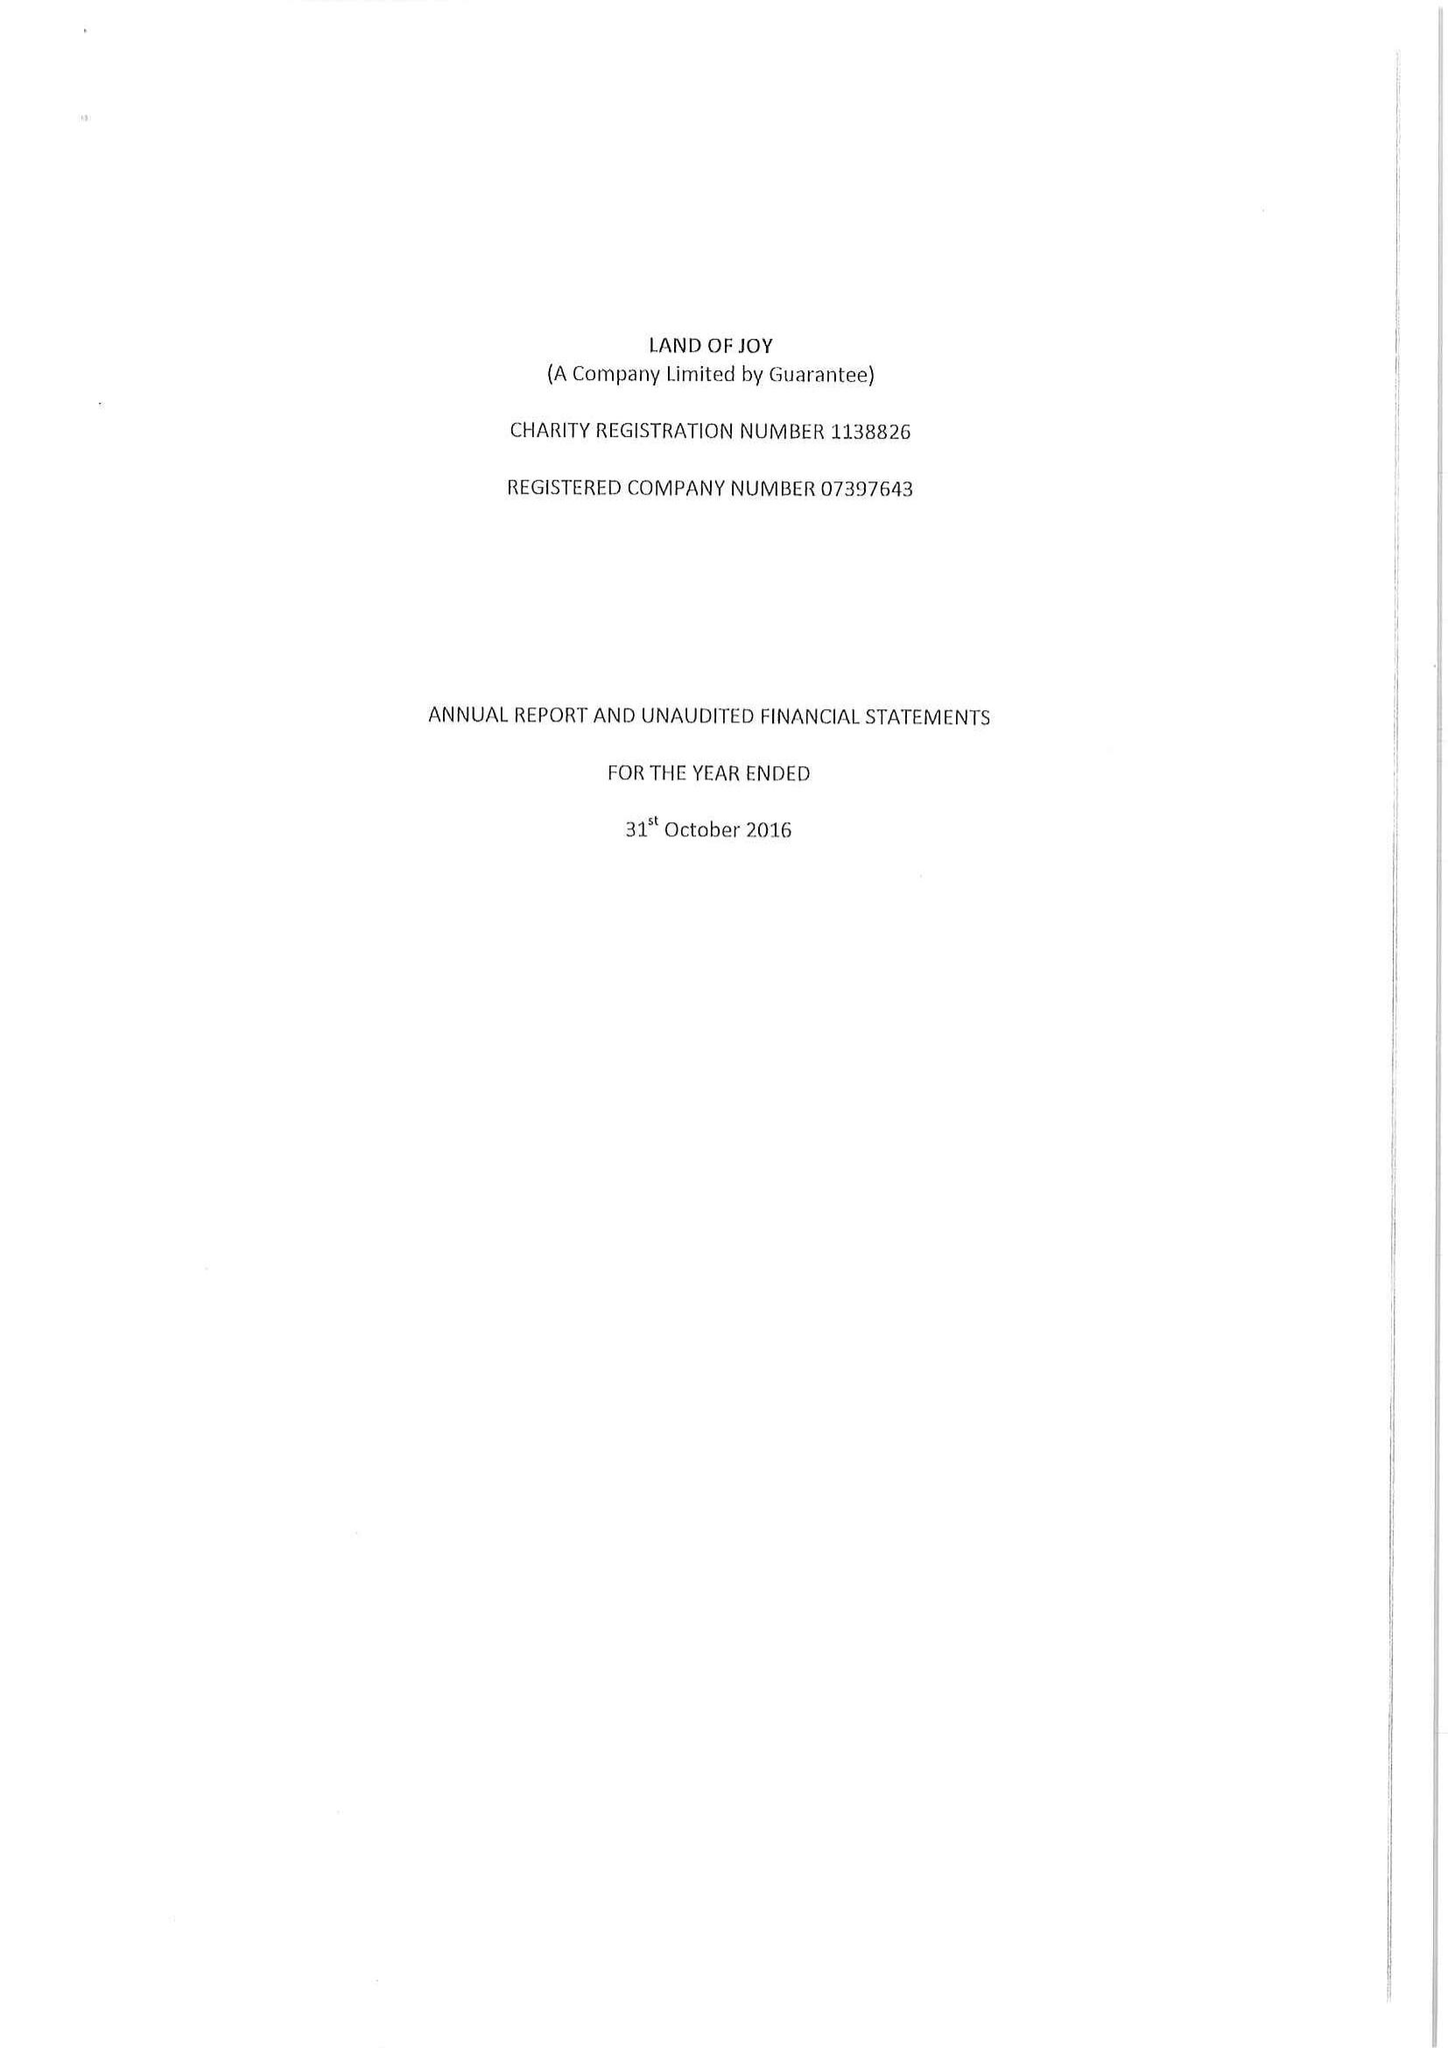What is the value for the charity_number?
Answer the question using a single word or phrase. 1138826 